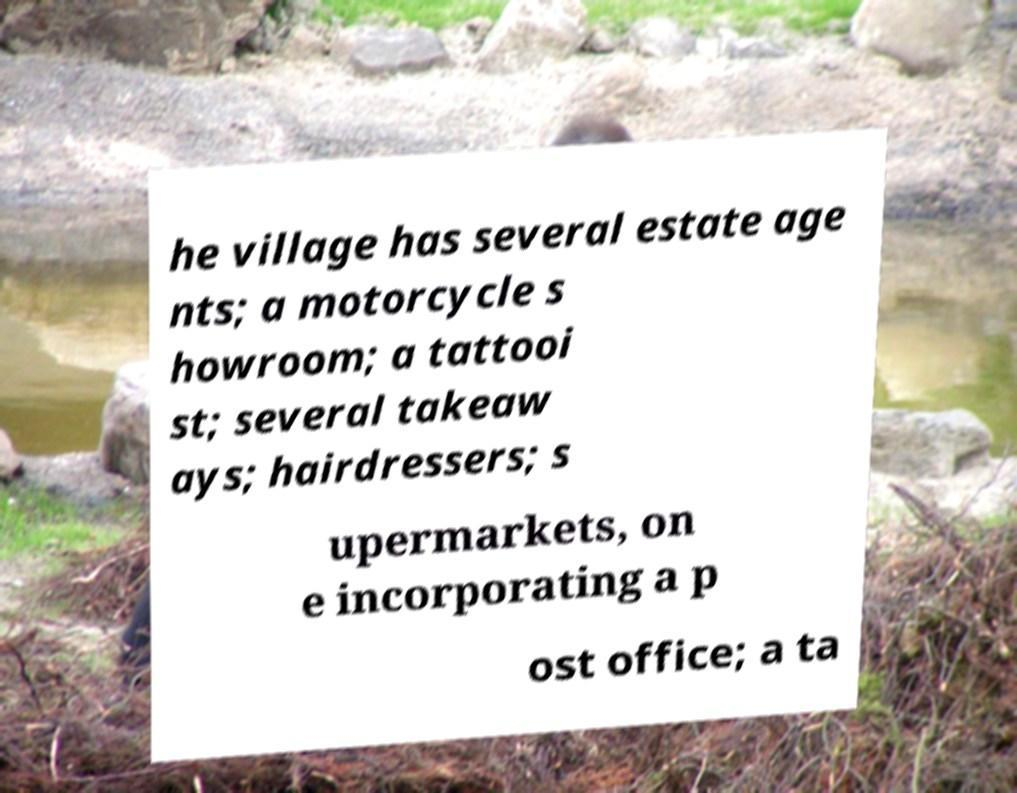For documentation purposes, I need the text within this image transcribed. Could you provide that? he village has several estate age nts; a motorcycle s howroom; a tattooi st; several takeaw ays; hairdressers; s upermarkets, on e incorporating a p ost office; a ta 